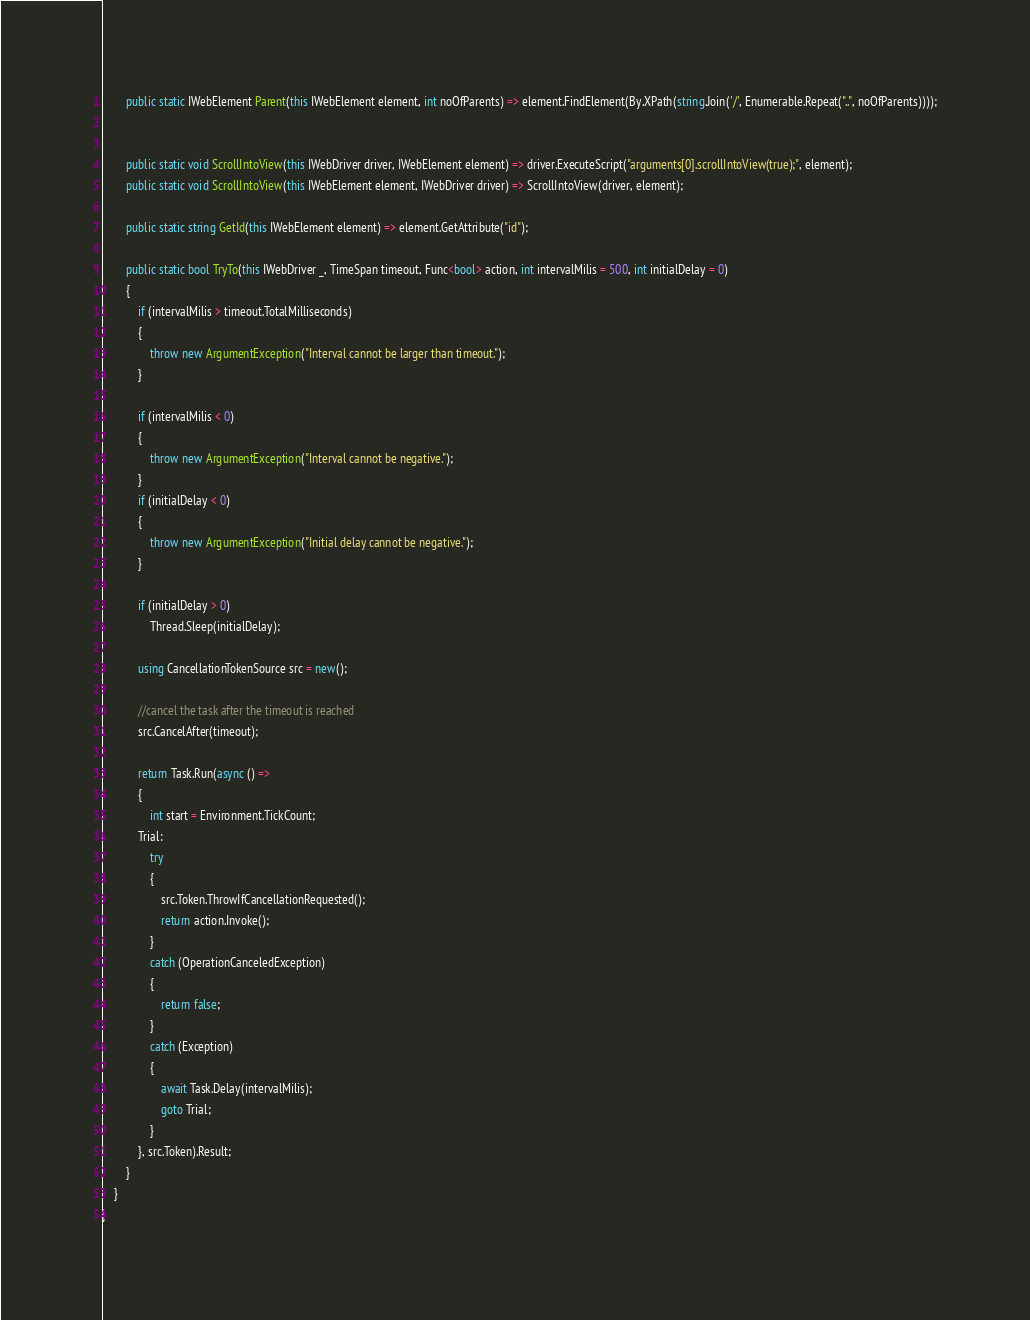<code> <loc_0><loc_0><loc_500><loc_500><_C#_>        public static IWebElement Parent(this IWebElement element, int noOfParents) => element.FindElement(By.XPath(string.Join('/', Enumerable.Repeat("..", noOfParents))));


        public static void ScrollIntoView(this IWebDriver driver, IWebElement element) => driver.ExecuteScript("arguments[0].scrollIntoView(true);", element);
        public static void ScrollIntoView(this IWebElement element, IWebDriver driver) => ScrollIntoView(driver, element);

        public static string GetId(this IWebElement element) => element.GetAttribute("id");

        public static bool TryTo(this IWebDriver _, TimeSpan timeout, Func<bool> action, int intervalMilis = 500, int initialDelay = 0)
        {
            if (intervalMilis > timeout.TotalMilliseconds)
            {
                throw new ArgumentException("Interval cannot be larger than timeout.");
            }

            if (intervalMilis < 0)
            {
                throw new ArgumentException("Interval cannot be negative.");
            }
            if (initialDelay < 0)
            {
                throw new ArgumentException("Initial delay cannot be negative.");
            }

            if (initialDelay > 0)
                Thread.Sleep(initialDelay);

            using CancellationTokenSource src = new();

            //cancel the task after the timeout is reached
            src.CancelAfter(timeout);

            return Task.Run(async () =>
            {
                int start = Environment.TickCount;
            Trial:
                try
                {
                    src.Token.ThrowIfCancellationRequested();
                    return action.Invoke();
                }
                catch (OperationCanceledException)
                {
                    return false;
                }
                catch (Exception)
                {
                    await Task.Delay(intervalMilis);
                    goto Trial;
                }
            }, src.Token).Result;
        }
    }
}</code> 